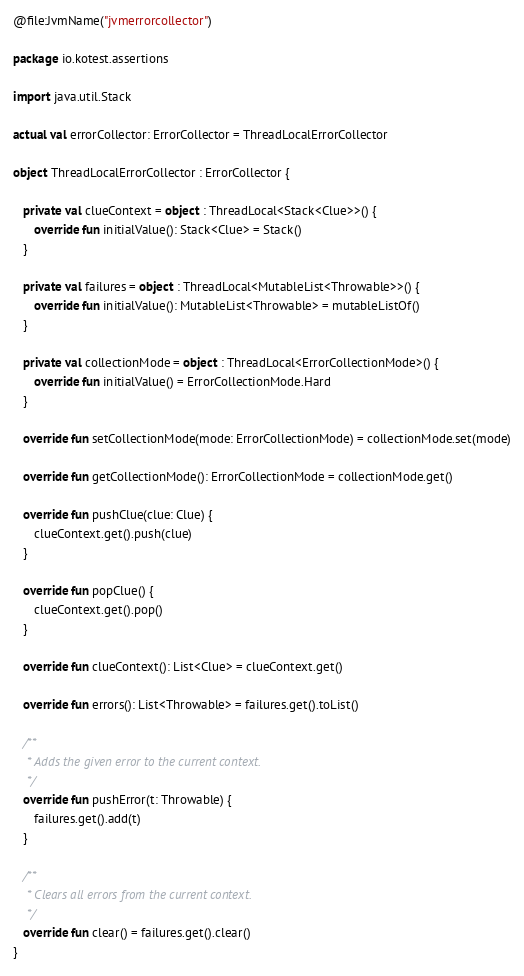Convert code to text. <code><loc_0><loc_0><loc_500><loc_500><_Kotlin_>@file:JvmName("jvmerrorcollector")

package io.kotest.assertions

import java.util.Stack

actual val errorCollector: ErrorCollector = ThreadLocalErrorCollector

object ThreadLocalErrorCollector : ErrorCollector {

   private val clueContext = object : ThreadLocal<Stack<Clue>>() {
      override fun initialValue(): Stack<Clue> = Stack()
   }

   private val failures = object : ThreadLocal<MutableList<Throwable>>() {
      override fun initialValue(): MutableList<Throwable> = mutableListOf()
   }

   private val collectionMode = object : ThreadLocal<ErrorCollectionMode>() {
      override fun initialValue() = ErrorCollectionMode.Hard
   }

   override fun setCollectionMode(mode: ErrorCollectionMode) = collectionMode.set(mode)

   override fun getCollectionMode(): ErrorCollectionMode = collectionMode.get()

   override fun pushClue(clue: Clue) {
      clueContext.get().push(clue)
   }

   override fun popClue() {
      clueContext.get().pop()
   }

   override fun clueContext(): List<Clue> = clueContext.get()

   override fun errors(): List<Throwable> = failures.get().toList()

   /**
    * Adds the given error to the current context.
    */
   override fun pushError(t: Throwable) {
      failures.get().add(t)
   }

   /**
    * Clears all errors from the current context.
    */
   override fun clear() = failures.get().clear()
}
</code> 